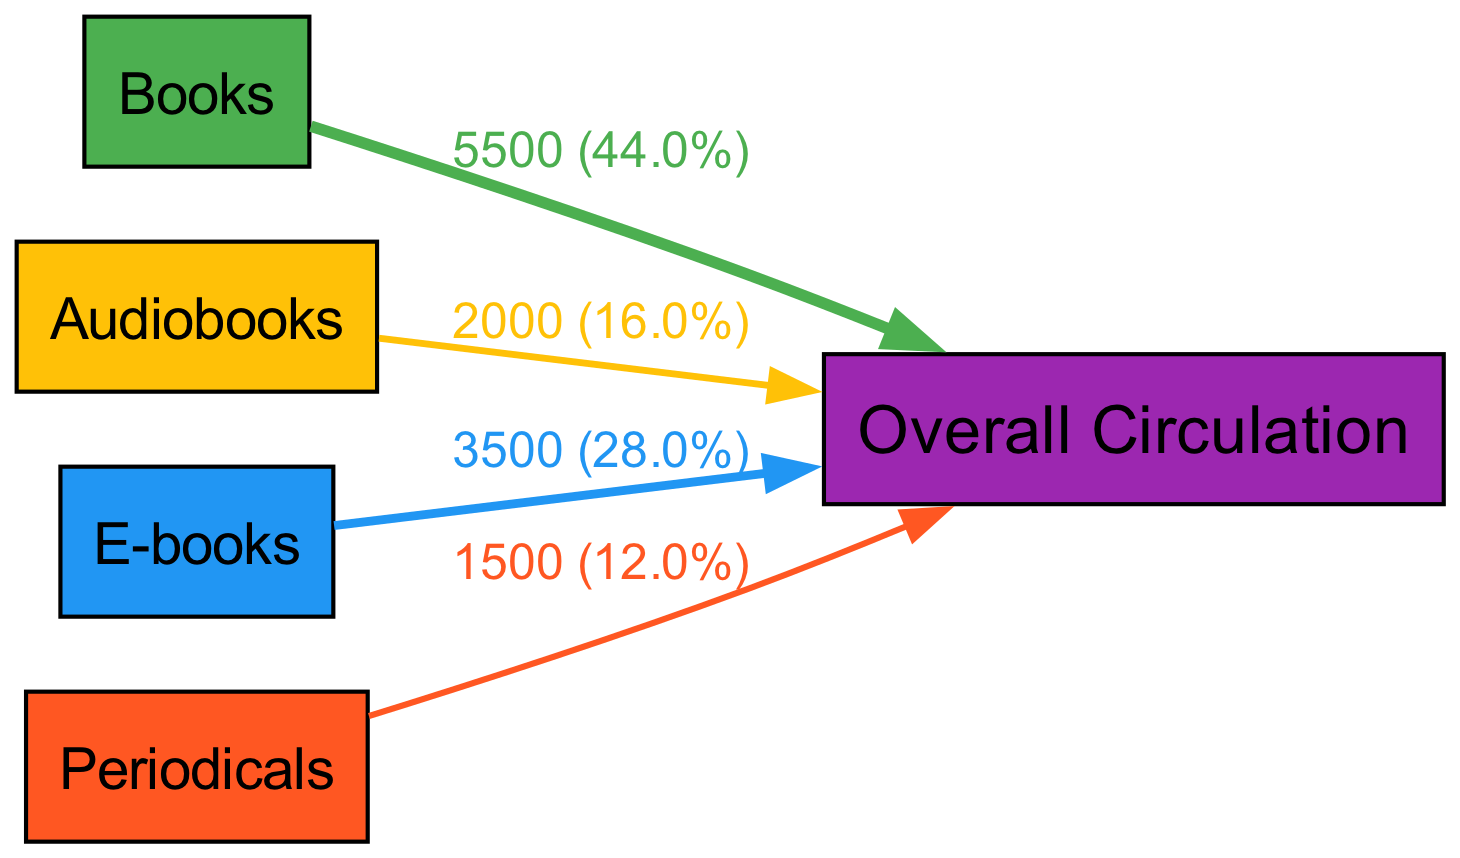What is the total circulation value represented in the diagram? To find the total circulation value, sum all the values of individual formats. The values are 5500 for books, 2000 for audiobooks, 3500 for e-books, and 1500 for periodicals. Adding these together gives: 5500 + 2000 + 3500 + 1500 = 13000.
Answer: 13000 Which format has the highest contribution to overall circulation? Review the values associated with each format. The maximum value is 5500, which corresponds to books.
Answer: Books What percentage of the overall circulation do audiobooks represent? Calculate the percentage by taking the value of audiobooks (2000) and dividing it by the total circulation (13000). Then multiply by 100: (2000 / 13000) * 100 = 15.4%.
Answer: 15.4% How many nodes are present in the diagram? Count the unique sources and the target node (overall circulation). There are four sources (books, audiobooks, e-books, periodicals) and one target. Thus, the total count is 4 + 1 = 5 nodes.
Answer: 5 What is the value of e-books contributing to overall circulation? Directly refer to the elements in the diagram, where e-books are listed with a value of 3500.
Answer: 3500 Which format has the least contribution to overall circulation? Compare all values associated with the formats and identify the smallest one. The smallest value is 1500, which corresponds to periodicals.
Answer: Periodicals What is the total contribution of periodicals and audiobooks combined? Add together the values of periodicals (1500) and audiobooks (2000). This results in: 1500 + 2000 = 3500.
Answer: 3500 What fraction of the total circulation do e-books and books represent combined? Find the combined value of e-books (3500) and books (5500), which totals 9000. Then, to find the fraction of the total circulation (13000): 9000/13000 simplifies to 9/13.
Answer: 9/13 